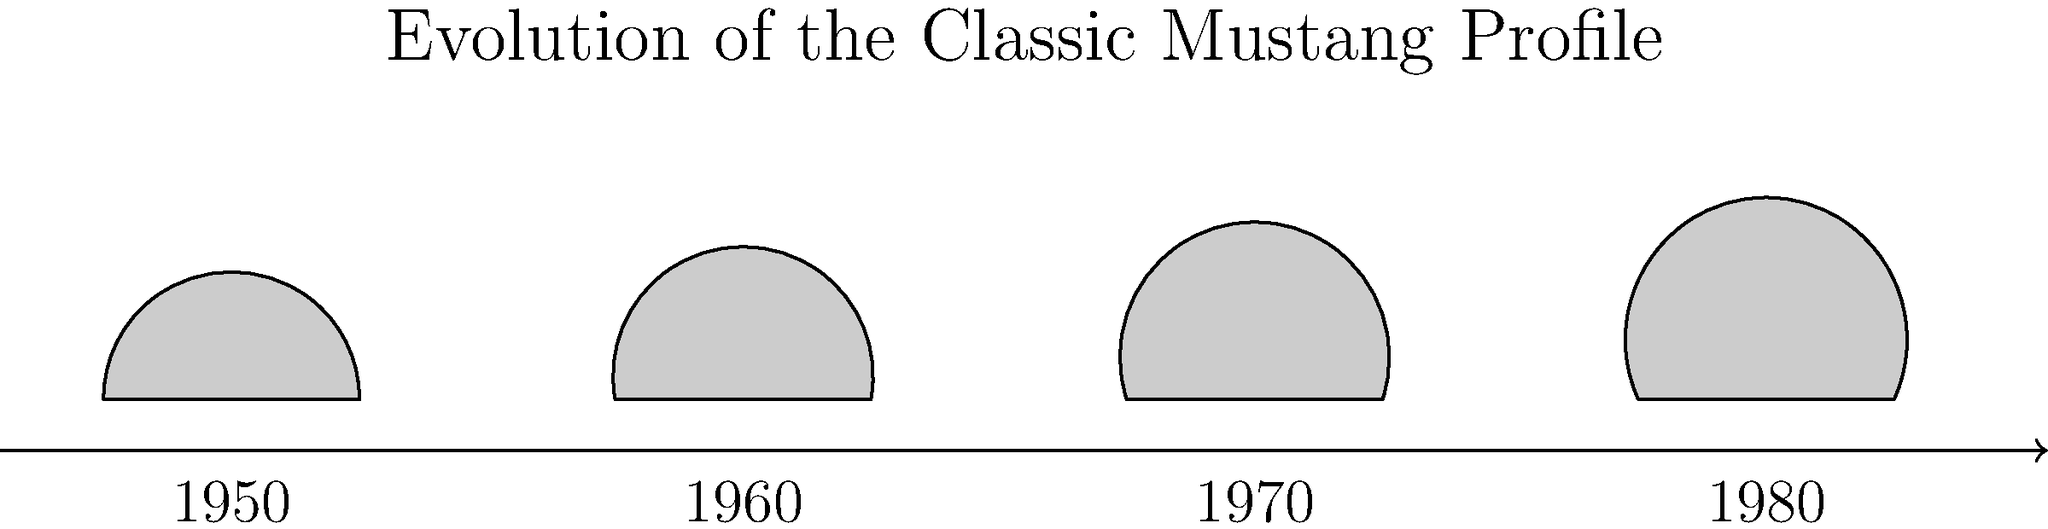Based on the timeline of profile sketches shown, which characteristic change in the Classic Mustang's design is most evident from the 1950s to the 1980s? To answer this question, we need to analyze the evolution of the Classic Mustang's profile sketches from the 1950s to the 1980s:

1. 1950s: The first sketch shows a relatively low profile with a gently sloping roofline.

2. 1960s: The second sketch indicates a slightly higher roofline, but the overall profile remains similar to the 1950s model.

3. 1970s: The third sketch shows a noticeable increase in the height of the roofline, with a more pronounced slope from front to back.

4. 1980s: The final sketch demonstrates the most significant change, with a much higher roofline and a more boxy, angular profile compared to earlier models.

Analyzing these changes, we can observe that the most evident characteristic change in the Classic Mustang's design from the 1950s to the 1980s is the gradual increase in the height of the roofline. This change reflects the broader automotive design trends of the era, moving from the sleek, low-slung profiles of the 1950s and early 1960s to the higher, more spacious cabins of the 1970s and 1980s.
Answer: Increasing height of the roofline 